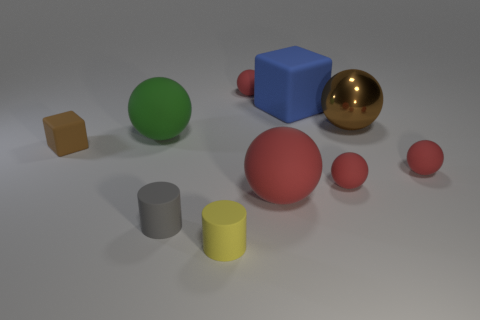Is the material of the brown block the same as the large blue object?
Provide a short and direct response. Yes. There is a brown thing on the left side of the small red object behind the cube that is on the right side of the large red rubber object; what shape is it?
Your response must be concise. Cube. The object that is on the left side of the small gray thing and right of the small rubber cube is made of what material?
Offer a very short reply. Rubber. There is a big sphere in front of the ball that is to the left of the red rubber sphere that is behind the brown block; what is its color?
Provide a succinct answer. Red. How many red things are large metallic balls or tiny rubber things?
Provide a short and direct response. 3. What number of other objects are there of the same size as the shiny ball?
Your answer should be very brief. 3. What number of large cyan matte cylinders are there?
Provide a short and direct response. 0. Is there any other thing that is the same shape as the green matte object?
Offer a terse response. Yes. Does the ball that is behind the brown sphere have the same material as the brown object that is on the right side of the tiny brown matte object?
Keep it short and to the point. No. What is the blue object made of?
Make the answer very short. Rubber. 